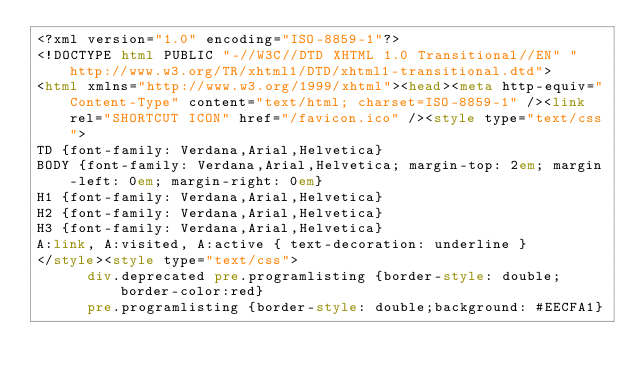<code> <loc_0><loc_0><loc_500><loc_500><_HTML_><?xml version="1.0" encoding="ISO-8859-1"?>
<!DOCTYPE html PUBLIC "-//W3C//DTD XHTML 1.0 Transitional//EN" "http://www.w3.org/TR/xhtml1/DTD/xhtml1-transitional.dtd">
<html xmlns="http://www.w3.org/1999/xhtml"><head><meta http-equiv="Content-Type" content="text/html; charset=ISO-8859-1" /><link rel="SHORTCUT ICON" href="/favicon.ico" /><style type="text/css">
TD {font-family: Verdana,Arial,Helvetica}
BODY {font-family: Verdana,Arial,Helvetica; margin-top: 2em; margin-left: 0em; margin-right: 0em}
H1 {font-family: Verdana,Arial,Helvetica}
H2 {font-family: Verdana,Arial,Helvetica}
H3 {font-family: Verdana,Arial,Helvetica}
A:link, A:visited, A:active { text-decoration: underline }
</style><style type="text/css">
      div.deprecated pre.programlisting {border-style: double;border-color:red}
      pre.programlisting {border-style: double;background: #EECFA1}</code> 